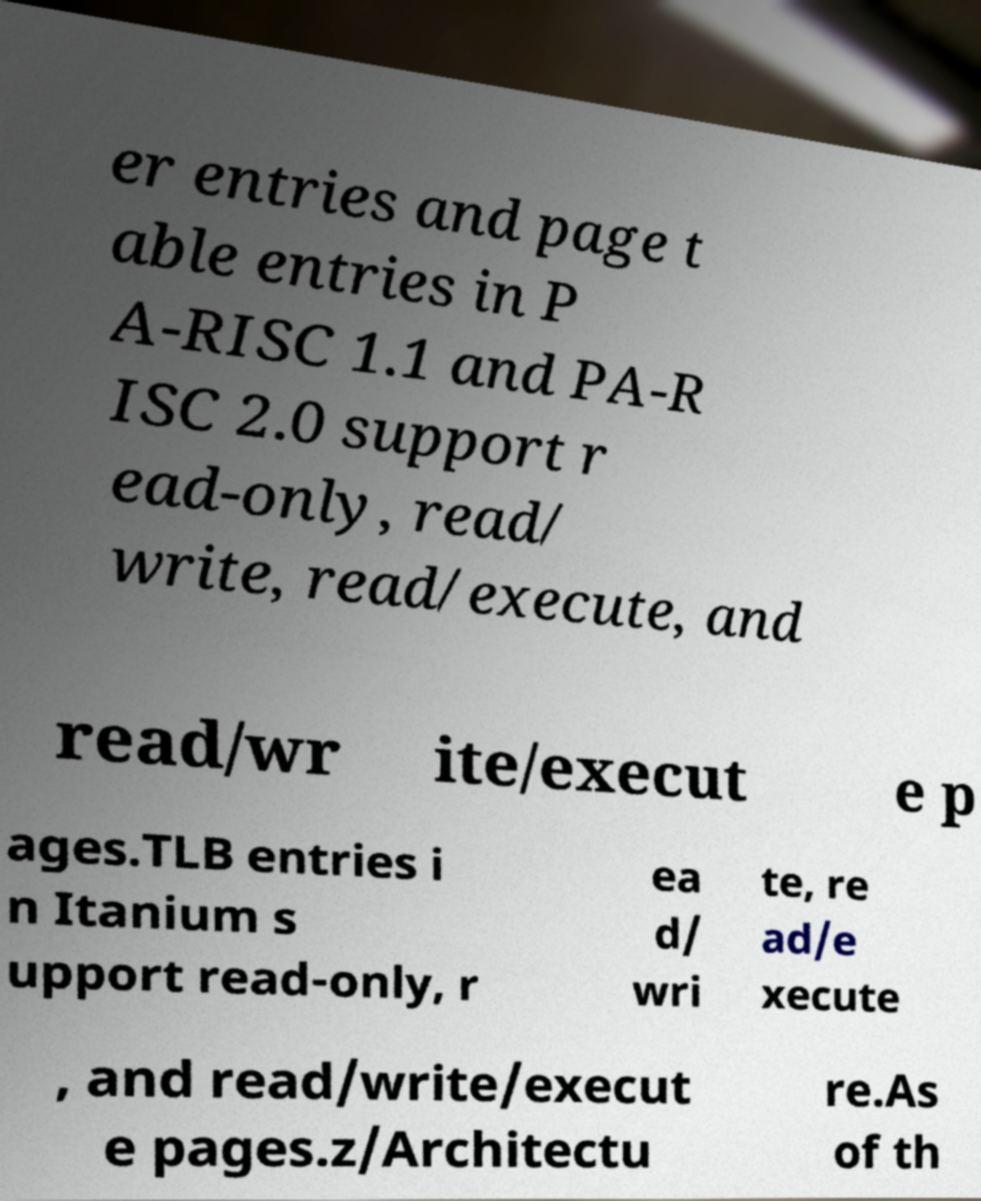Can you accurately transcribe the text from the provided image for me? er entries and page t able entries in P A-RISC 1.1 and PA-R ISC 2.0 support r ead-only, read/ write, read/execute, and read/wr ite/execut e p ages.TLB entries i n Itanium s upport read-only, r ea d/ wri te, re ad/e xecute , and read/write/execut e pages.z/Architectu re.As of th 